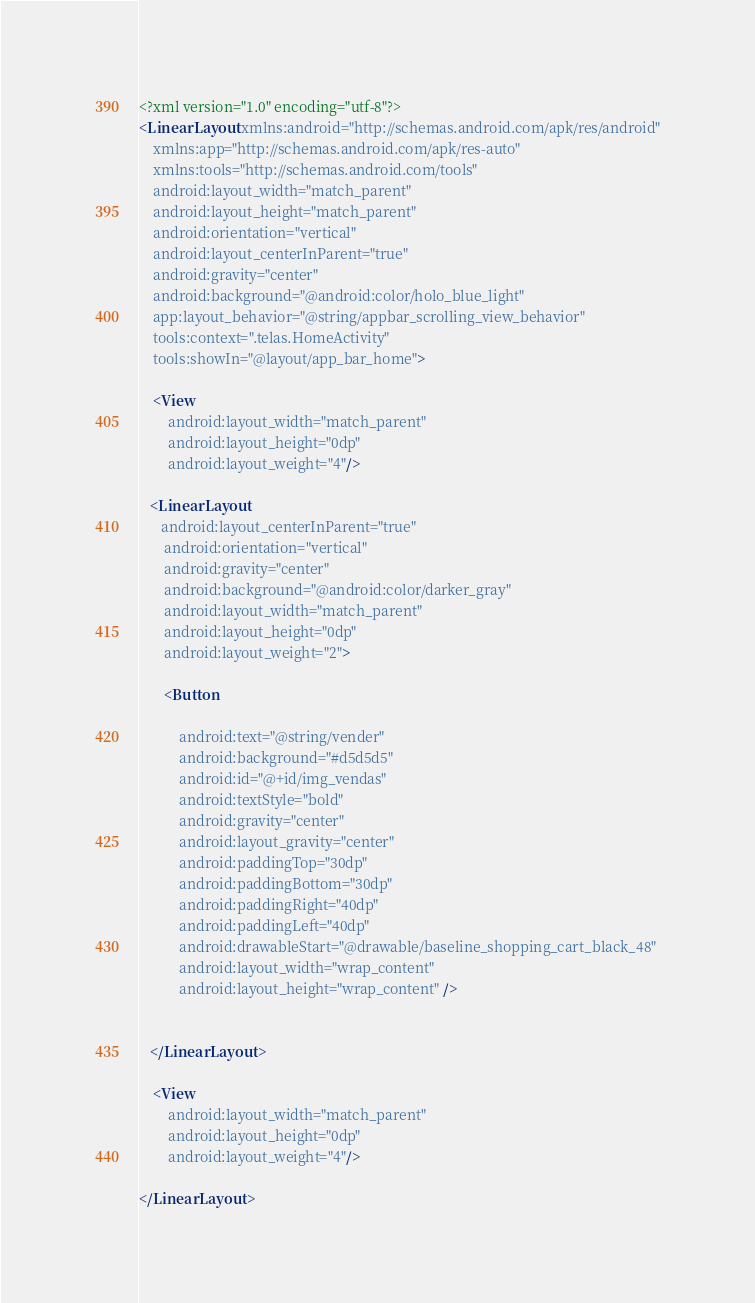Convert code to text. <code><loc_0><loc_0><loc_500><loc_500><_XML_><?xml version="1.0" encoding="utf-8"?>
<LinearLayout xmlns:android="http://schemas.android.com/apk/res/android"
    xmlns:app="http://schemas.android.com/apk/res-auto"
    xmlns:tools="http://schemas.android.com/tools"
    android:layout_width="match_parent"
    android:layout_height="match_parent"
    android:orientation="vertical"
    android:layout_centerInParent="true"
    android:gravity="center"
    android:background="@android:color/holo_blue_light"
    app:layout_behavior="@string/appbar_scrolling_view_behavior"
    tools:context=".telas.HomeActivity"
    tools:showIn="@layout/app_bar_home">

    <View
        android:layout_width="match_parent"
        android:layout_height="0dp"
        android:layout_weight="4"/>

   <LinearLayout
      android:layout_centerInParent="true"
       android:orientation="vertical"
       android:gravity="center"
       android:background="@android:color/darker_gray"
       android:layout_width="match_parent"
       android:layout_height="0dp"
       android:layout_weight="2">

       <Button

           android:text="@string/vender"
           android:background="#d5d5d5"
           android:id="@+id/img_vendas"
           android:textStyle="bold"
           android:gravity="center"
           android:layout_gravity="center"
           android:paddingTop="30dp"
           android:paddingBottom="30dp"
           android:paddingRight="40dp"
           android:paddingLeft="40dp"
           android:drawableStart="@drawable/baseline_shopping_cart_black_48"
           android:layout_width="wrap_content"
           android:layout_height="wrap_content" />


   </LinearLayout>

    <View
        android:layout_width="match_parent"
        android:layout_height="0dp"
        android:layout_weight="4"/>

</LinearLayout></code> 